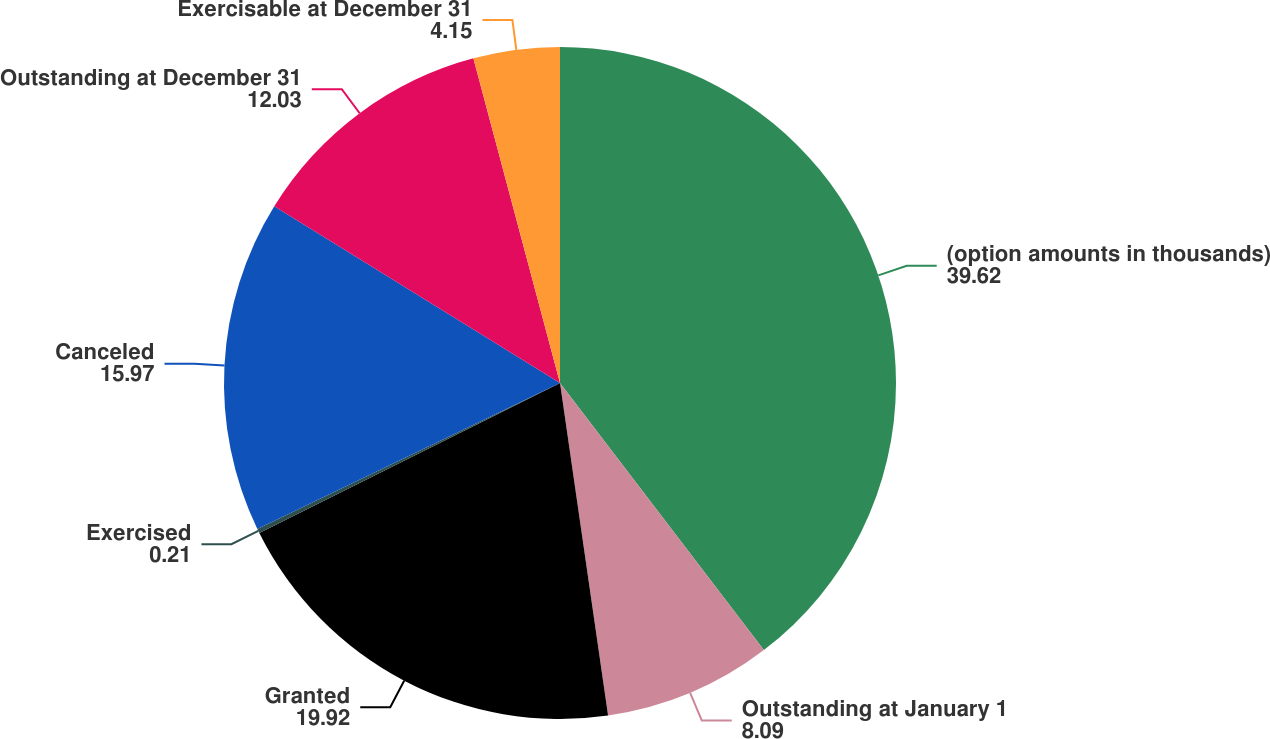<chart> <loc_0><loc_0><loc_500><loc_500><pie_chart><fcel>(option amounts in thousands)<fcel>Outstanding at January 1<fcel>Granted<fcel>Exercised<fcel>Canceled<fcel>Outstanding at December 31<fcel>Exercisable at December 31<nl><fcel>39.62%<fcel>8.09%<fcel>19.92%<fcel>0.21%<fcel>15.97%<fcel>12.03%<fcel>4.15%<nl></chart> 